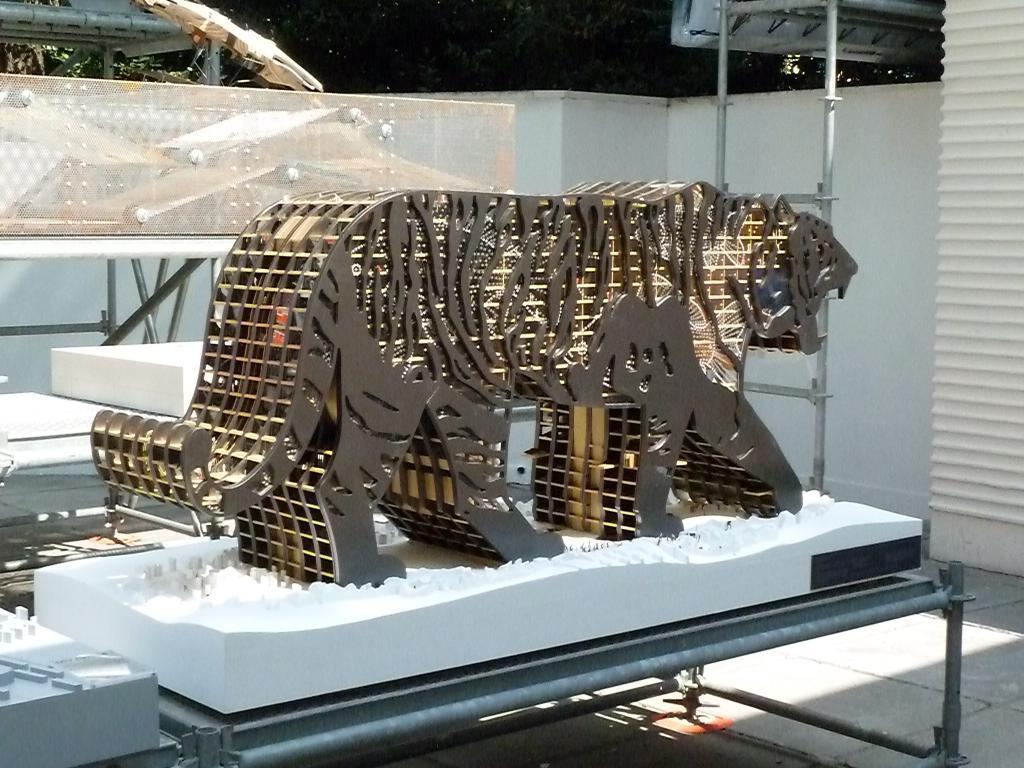Describe this image in one or two sentences. Here we can see a statue of a tiger. This is floor. In the background we can see a wall and poles. 